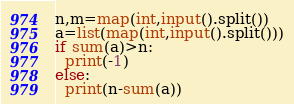<code> <loc_0><loc_0><loc_500><loc_500><_Python_>n,m=map(int,input().split())
a=list(map(int,input().split()))
if sum(a)>n:
  print(-1)
else:
  print(n-sum(a))</code> 